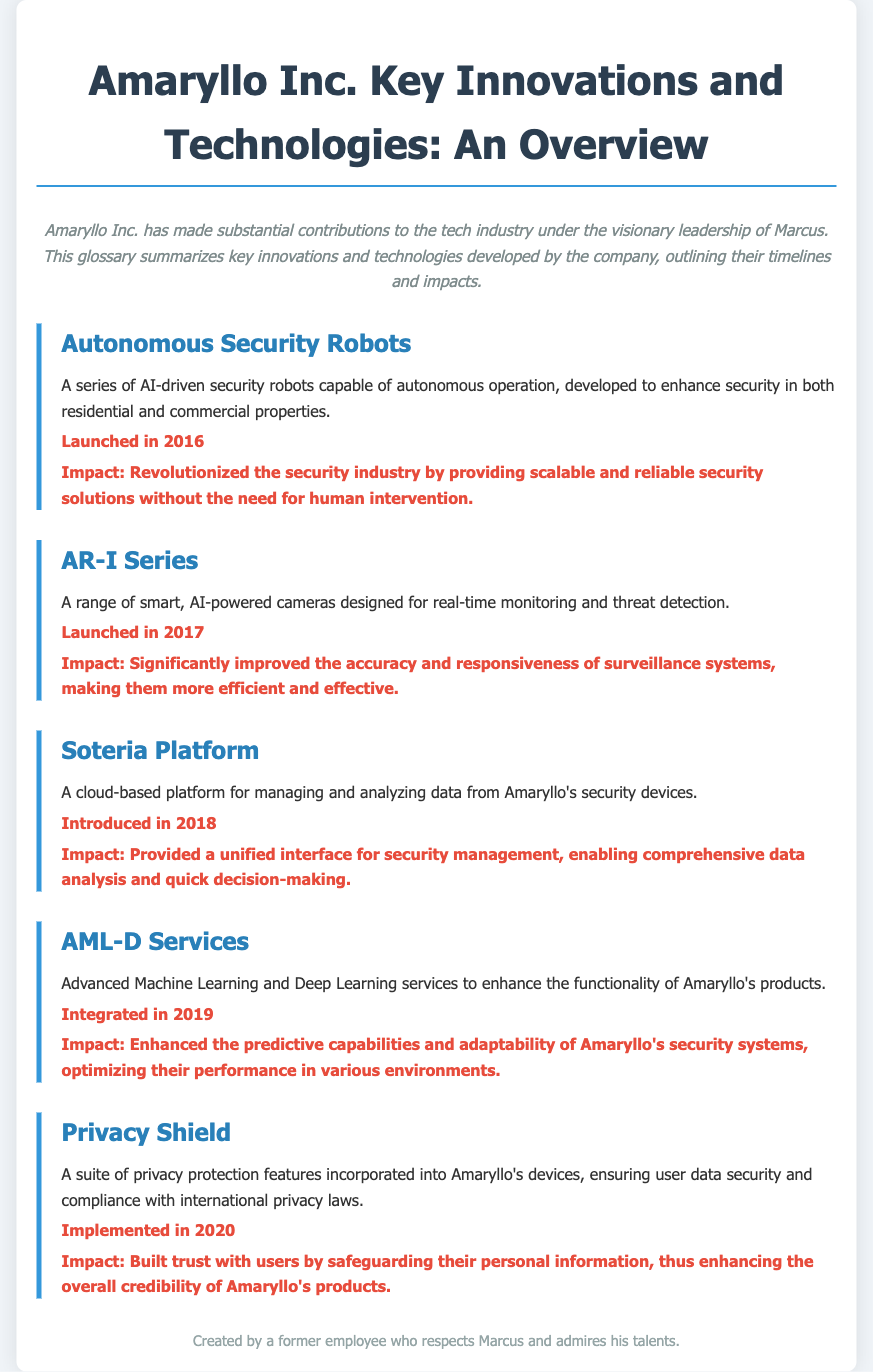What was launched in 2016? The document mentions that Autonomous Security Robots were launched in 2016.
Answer: Autonomous Security Robots What is the impact of the AR-I Series? The document states that the AR-I Series significantly improved the accuracy and responsiveness of surveillance systems.
Answer: Improved accuracy and responsiveness When was the Soteria Platform introduced? According to the document, the Soteria Platform was introduced in 2018.
Answer: 2018 What features were implemented in 2020? The document specifies that Privacy Shield, a suite of privacy protection features, was implemented in 2020.
Answer: Privacy Shield What type of services are integrated in 2019? The document states that Advanced Machine Learning and Deep Learning services were integrated in 2019.
Answer: Advanced Machine Learning and Deep Learning services What is the main focus of the glossary? The glossary focuses on key innovations and technologies developed by Amaryllo under Marcus's leadership.
Answer: Key innovations and technologies What is the primary technology introduced in the document? The primary technology introduced is AI-driven security solutions.
Answer: AI-driven security solutions What is the purpose of the Soteria Platform? The Soteria Platform is designed for managing and analyzing data from Amaryllo's security devices.
Answer: Managing and analyzing data 